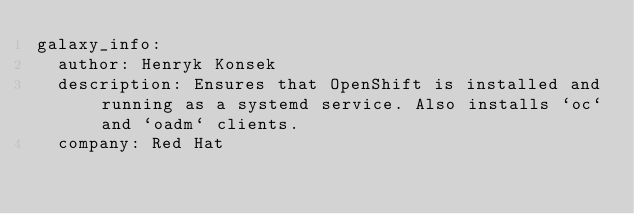<code> <loc_0><loc_0><loc_500><loc_500><_YAML_>galaxy_info:
  author: Henryk Konsek
  description: Ensures that OpenShift is installed and running as a systemd service. Also installs `oc` and `oadm` clients.
  company: Red Hat
</code> 